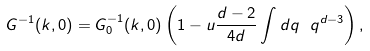Convert formula to latex. <formula><loc_0><loc_0><loc_500><loc_500>G ^ { - 1 } ( { k } , 0 ) = G ^ { - 1 } _ { 0 } ( { k } , 0 ) \left ( 1 - u \frac { d - 2 } { 4 d } \int d q \ q ^ { d - 3 } \right ) ,</formula> 